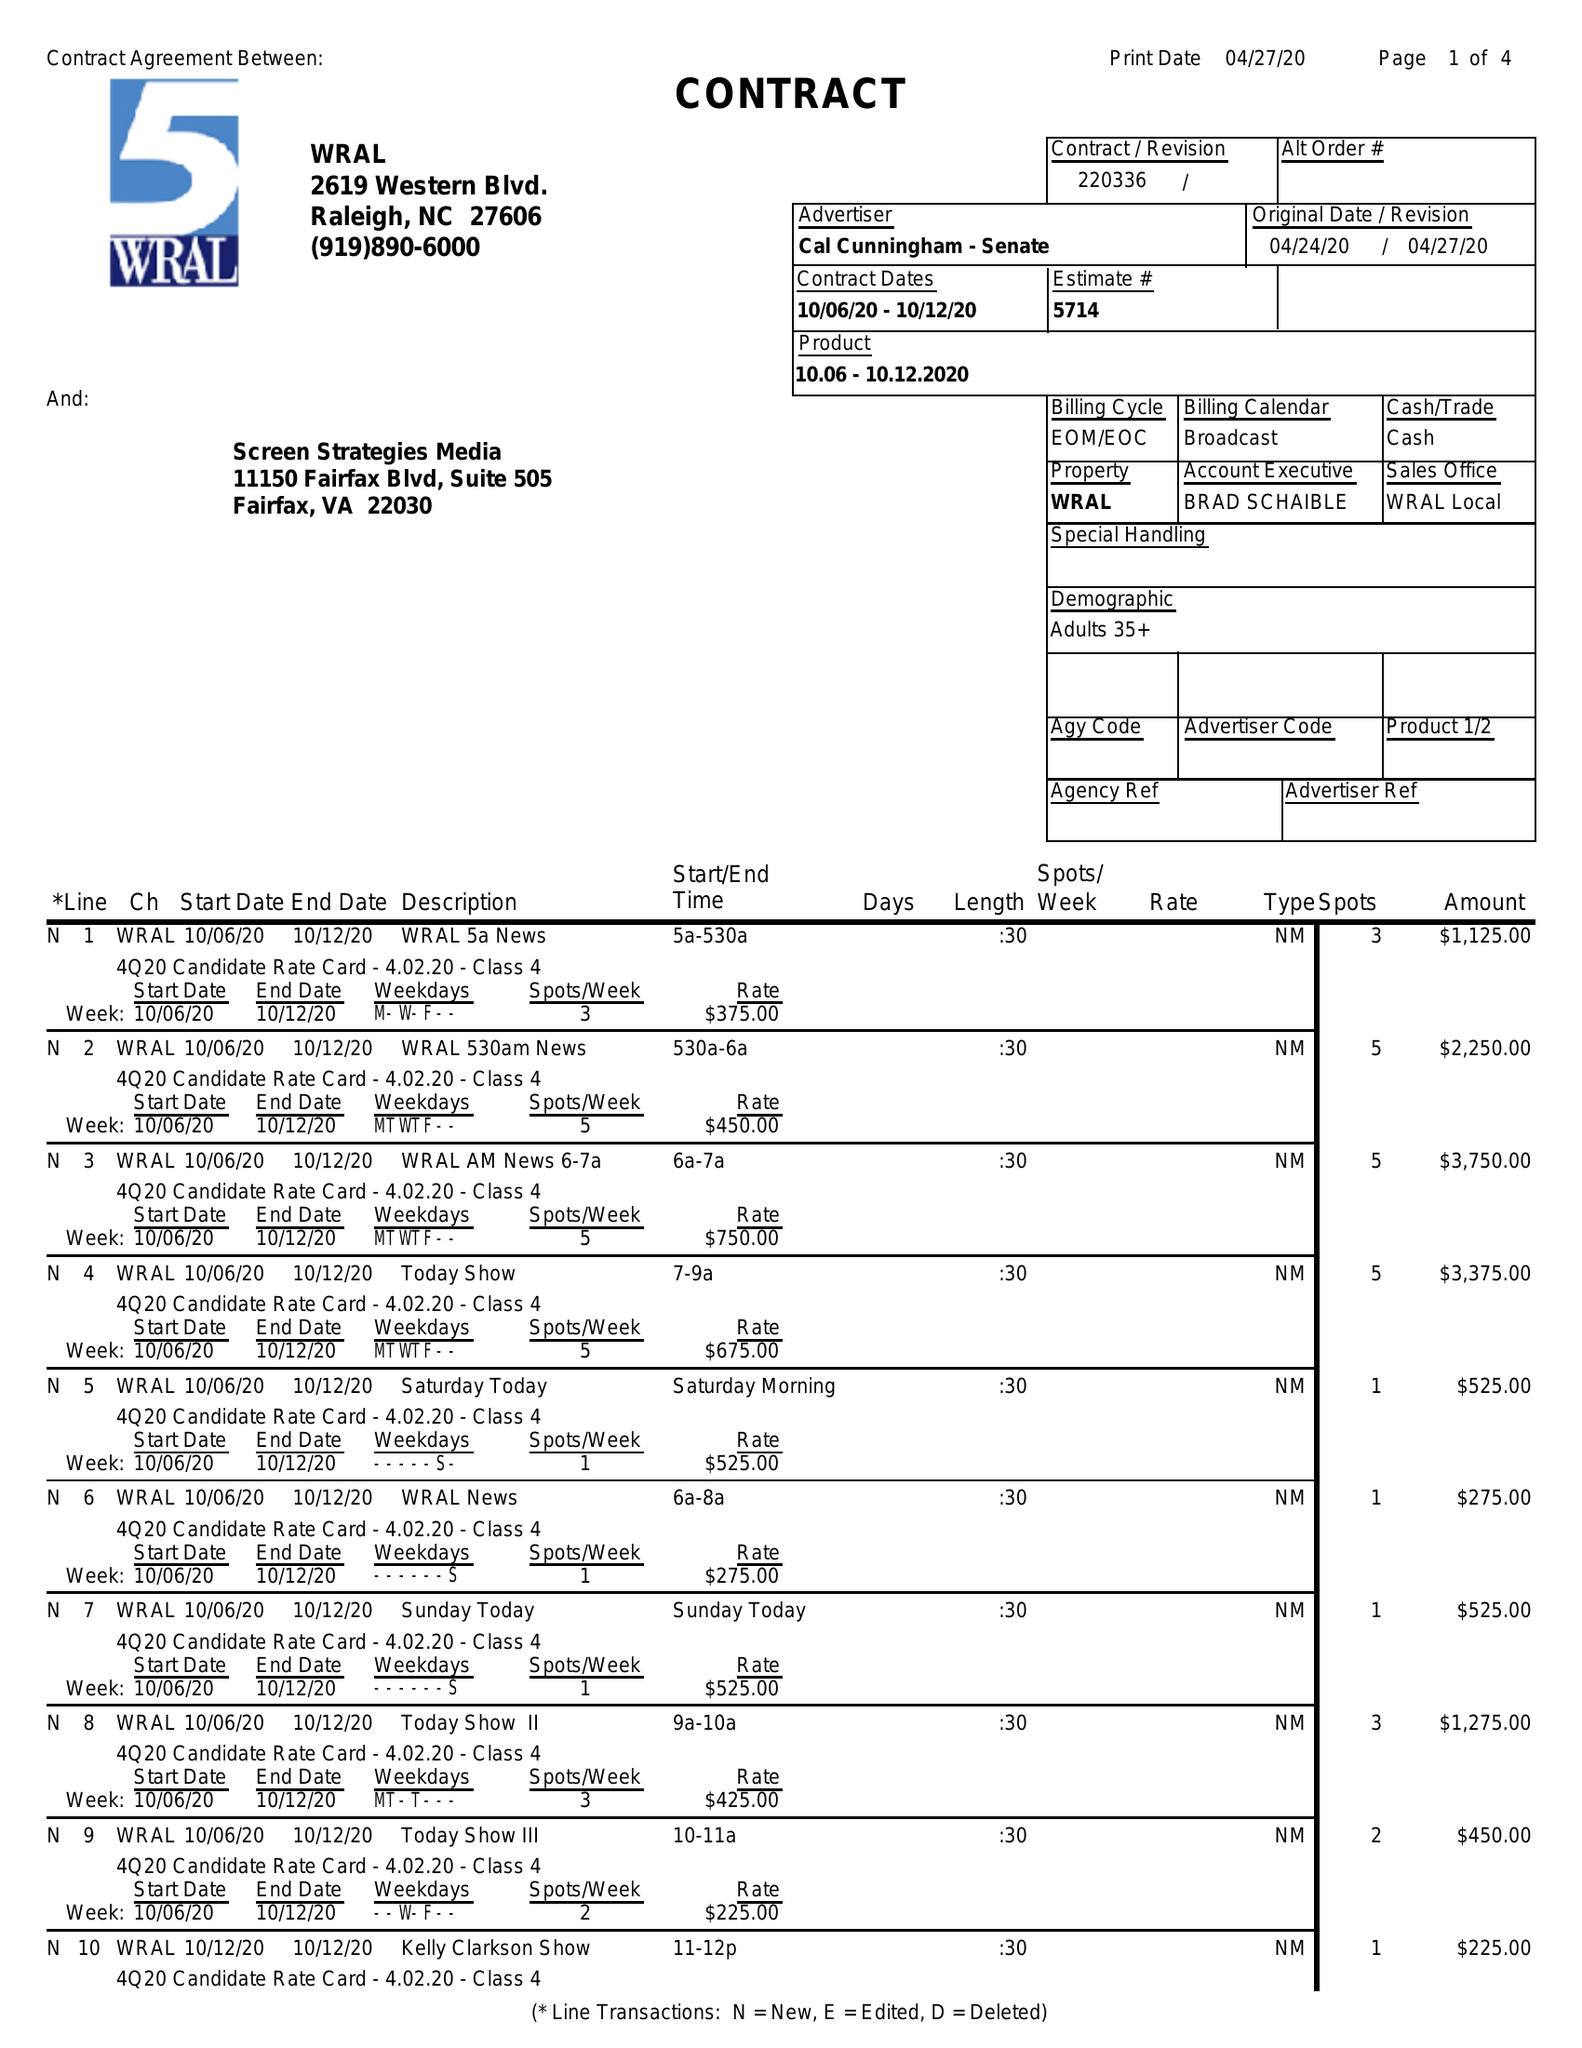What is the value for the flight_to?
Answer the question using a single word or phrase. 10/12/20 